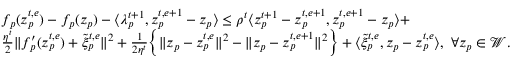<formula> <loc_0><loc_0><loc_500><loc_500>\begin{array} { r l } & { f _ { p } ( z _ { p } ^ { t , e } ) - f _ { p } ( z _ { p } ) - \langle \lambda _ { p } ^ { t + 1 } , z _ { p } ^ { t , e + 1 } - z _ { p } \rangle \leq \rho ^ { t } \langle z _ { p } ^ { t + 1 } - z _ { p } ^ { t , e + 1 } , z _ { p } ^ { t , e + 1 } - z _ { p } \rangle + } \\ & { \frac { \eta ^ { t } } { 2 } \| f _ { p } ^ { \prime } ( z _ { p } ^ { t , e } ) + \tilde { \xi } _ { p } ^ { t , e } \| ^ { 2 } + \frac { 1 } { 2 \eta ^ { t } } \left \{ \| z _ { p } - z _ { p } ^ { t , e } \| ^ { 2 } - \| z _ { p } - z _ { p } ^ { t , e + 1 } \| ^ { 2 } \right \} + \langle \tilde { \xi } _ { p } ^ { t , e } , z _ { p } - z _ { p } ^ { t , e } \rangle , \ \forall z _ { p } \in \mathcal { W } . } \end{array}</formula> 